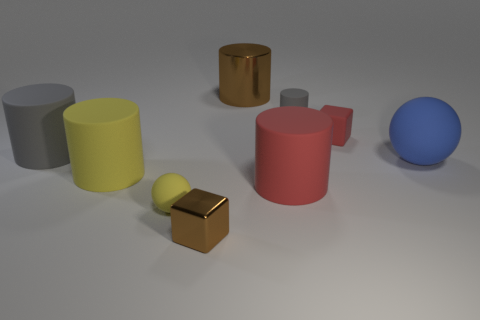There is a cube that is the same color as the metal cylinder; what is it made of?
Your answer should be compact. Metal. What shape is the rubber object that is the same color as the small ball?
Provide a short and direct response. Cylinder. What is the size of the thing that is in front of the red rubber cylinder and behind the small brown cube?
Your response must be concise. Small. Are there any gray cylinders on the right side of the tiny yellow object?
Your response must be concise. Yes. How many things are brown objects that are in front of the blue matte thing or yellow cylinders?
Keep it short and to the point. 2. There is a block that is to the right of the tiny metal object; how many brown cylinders are on the right side of it?
Keep it short and to the point. 0. Are there fewer large yellow rubber things right of the large yellow cylinder than big things right of the large brown shiny cylinder?
Provide a succinct answer. Yes. The brown thing behind the sphere that is right of the brown block is what shape?
Your answer should be compact. Cylinder. How many other objects are the same material as the small cylinder?
Offer a terse response. 6. Is there anything else that is the same size as the red cylinder?
Your answer should be very brief. Yes. 